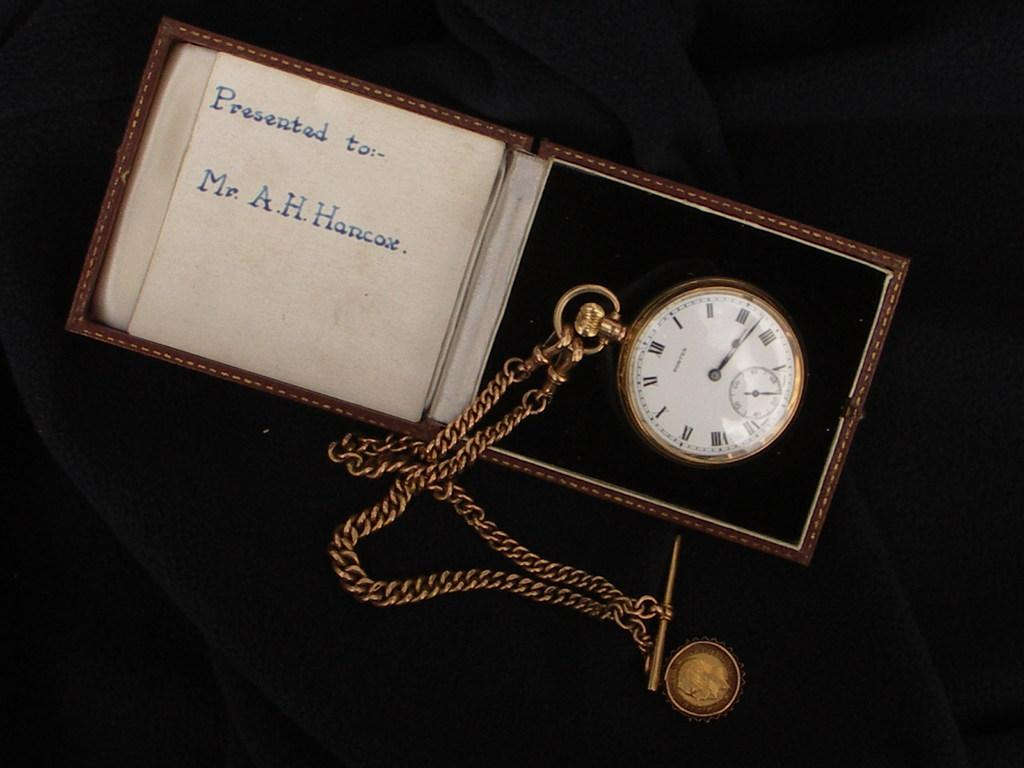<image>
Relay a brief, clear account of the picture shown. A clock in a box given to Mr. A, H. Hancox. 